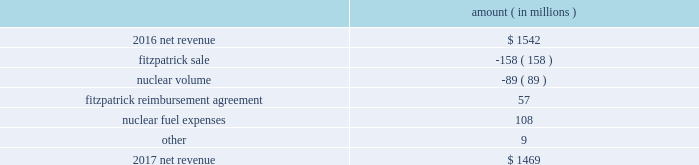The regulatory credit resulting from reduction of the federal corporate income tax rate variance is due to the reduction of the vidalia purchased power agreement regulatory liability by $ 30.5 million and the reduction of the louisiana act 55 financing savings obligation regulatory liabilities by $ 25 million as a result of the enactment of the tax cuts and jobs act , in december 2017 , which lowered the federal corporate income tax rate from 35% ( 35 % ) to 21% ( 21 % ) .
The effects of the tax cuts and jobs act are discussed further in note 3 to the financial statements .
The grand gulf recovery variance is primarily due to increased recovery of higher operating costs .
The louisiana act 55 financing savings obligation variance results from a regulatory charge in 2016 for tax savings to be shared with customers per an agreement approved by the lpsc .
The tax savings resulted from the 2010-2011 irs audit settlement on the treatment of the louisiana act 55 financing of storm costs for hurricane gustav and hurricane ike .
See note 3 to the financial statements for additional discussion of the settlement and benefit sharing .
The volume/weather variance is primarily due to the effect of less favorable weather on residential and commercial sales , partially offset by an increase in industrial usage .
The increase in industrial usage is primarily due to new customers in the primary metals industry and expansion projects and an increase in demand for existing customers in the chlor-alkali industry .
Entergy wholesale commodities following is an analysis of the change in net revenue comparing 2017 to 2016 .
Amount ( in millions ) .
As shown in the table above , net revenue for entergy wholesale commodities decreased by approximately $ 73 million in 2017 primarily due to the absence of net revenue from the fitzpatrick plant after it was sold to exelon in march 2017 and lower volume in the entergy wholesale commodities nuclear fleet resulting from more outage days in 2017 as compared to 2016 .
The decrease was partially offset by an increase resulting from the reimbursement agreement with exelon pursuant to which exelon reimbursed entergy for specified out-of-pocket costs associated with preparing for the refueling and operation of fitzpatrick that otherwise would have been avoided had entergy shut down fitzpatrick in january 2017 and a decrease in nuclear fuel expenses primarily related to the impairments of the indian point 2 , indian point 3 , and palisades plants and related assets .
Revenues received from exelon in 2017 under the reimbursement agreement are offset by other operation and maintenance expenses and taxes other than income taxes and had no effect on net income .
See note 14 to the financial statements for discussion of the sale of fitzpatrick , the reimbursement agreement with exelon , and the impairments and related charges .
Entergy corporation and subsidiaries management 2019s financial discussion and analysis .
What is the net change in net revenue during 2017? 
Computations: (1469 - 1542)
Answer: -73.0. 